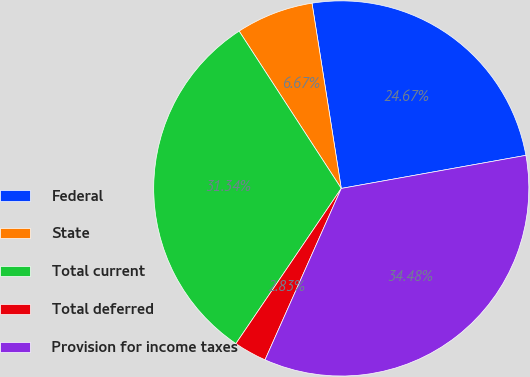Convert chart to OTSL. <chart><loc_0><loc_0><loc_500><loc_500><pie_chart><fcel>Federal<fcel>State<fcel>Total current<fcel>Total deferred<fcel>Provision for income taxes<nl><fcel>24.67%<fcel>6.67%<fcel>31.34%<fcel>2.83%<fcel>34.48%<nl></chart> 